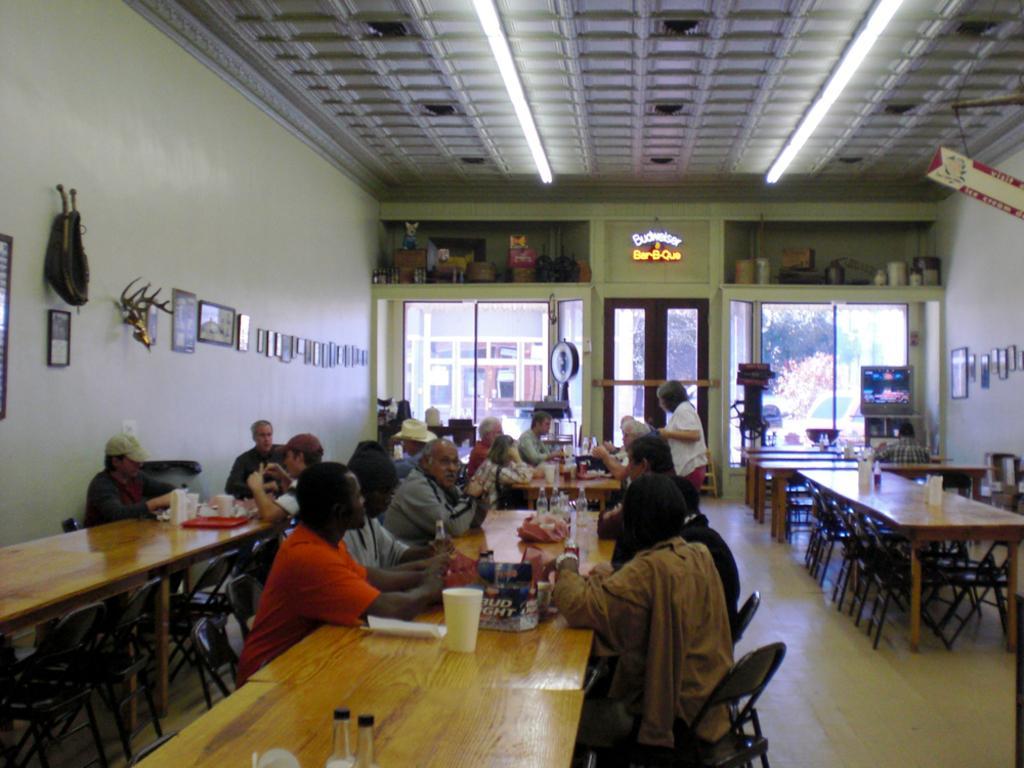How would you summarize this image in a sentence or two? In this image there are group of people who are sitting on chairs and there are many tables. On the table we could see some glasses, plates, bottles and cups and some objects are there on the tables. And on the background there are some windows and on the top there is ceiling and some lights are there, and on the left side there are some photo frames on the wall and on the right side there is one television and some photo frames are there. 